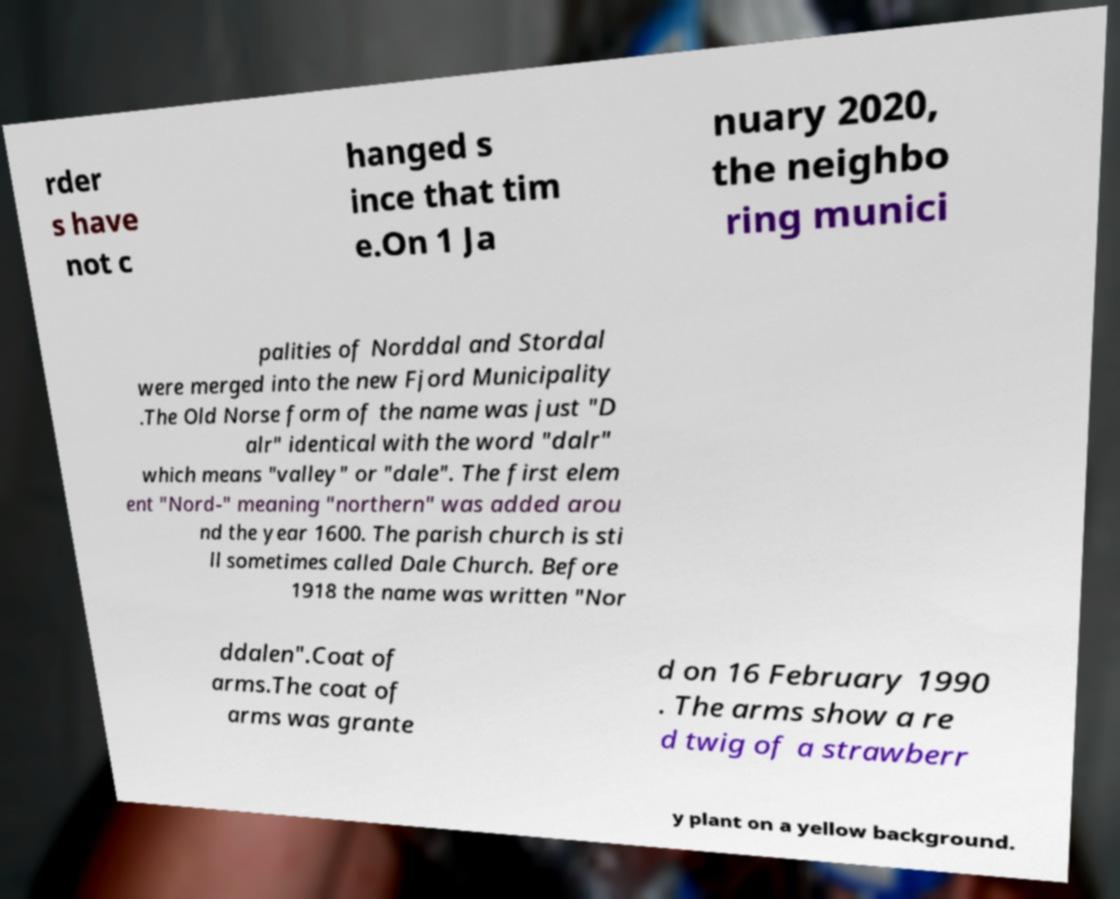What messages or text are displayed in this image? I need them in a readable, typed format. rder s have not c hanged s ince that tim e.On 1 Ja nuary 2020, the neighbo ring munici palities of Norddal and Stordal were merged into the new Fjord Municipality .The Old Norse form of the name was just "D alr" identical with the word "dalr" which means "valley" or "dale". The first elem ent "Nord-" meaning "northern" was added arou nd the year 1600. The parish church is sti ll sometimes called Dale Church. Before 1918 the name was written "Nor ddalen".Coat of arms.The coat of arms was grante d on 16 February 1990 . The arms show a re d twig of a strawberr y plant on a yellow background. 